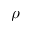<formula> <loc_0><loc_0><loc_500><loc_500>\rho</formula> 